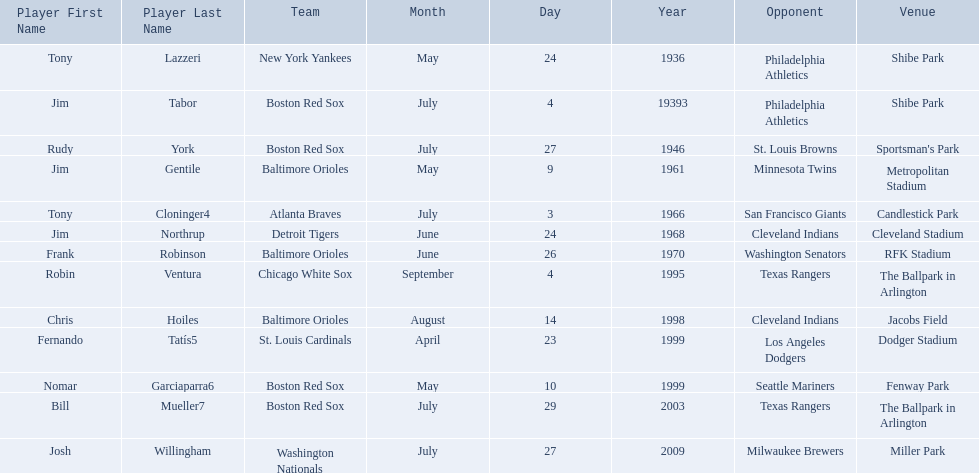Who are all the opponents? Philadelphia Athletics, Philadelphia Athletics, St. Louis Browns, Minnesota Twins, San Francisco Giants, Cleveland Indians, Washington Senators, Texas Rangers, Cleveland Indians, Los Angeles Dodgers, Seattle Mariners, Texas Rangers, Milwaukee Brewers. What teams played on july 27, 1946? Boston Red Sox, July 27, 1946, St. Louis Browns. Who was the opponent in this game? St. Louis Browns. 